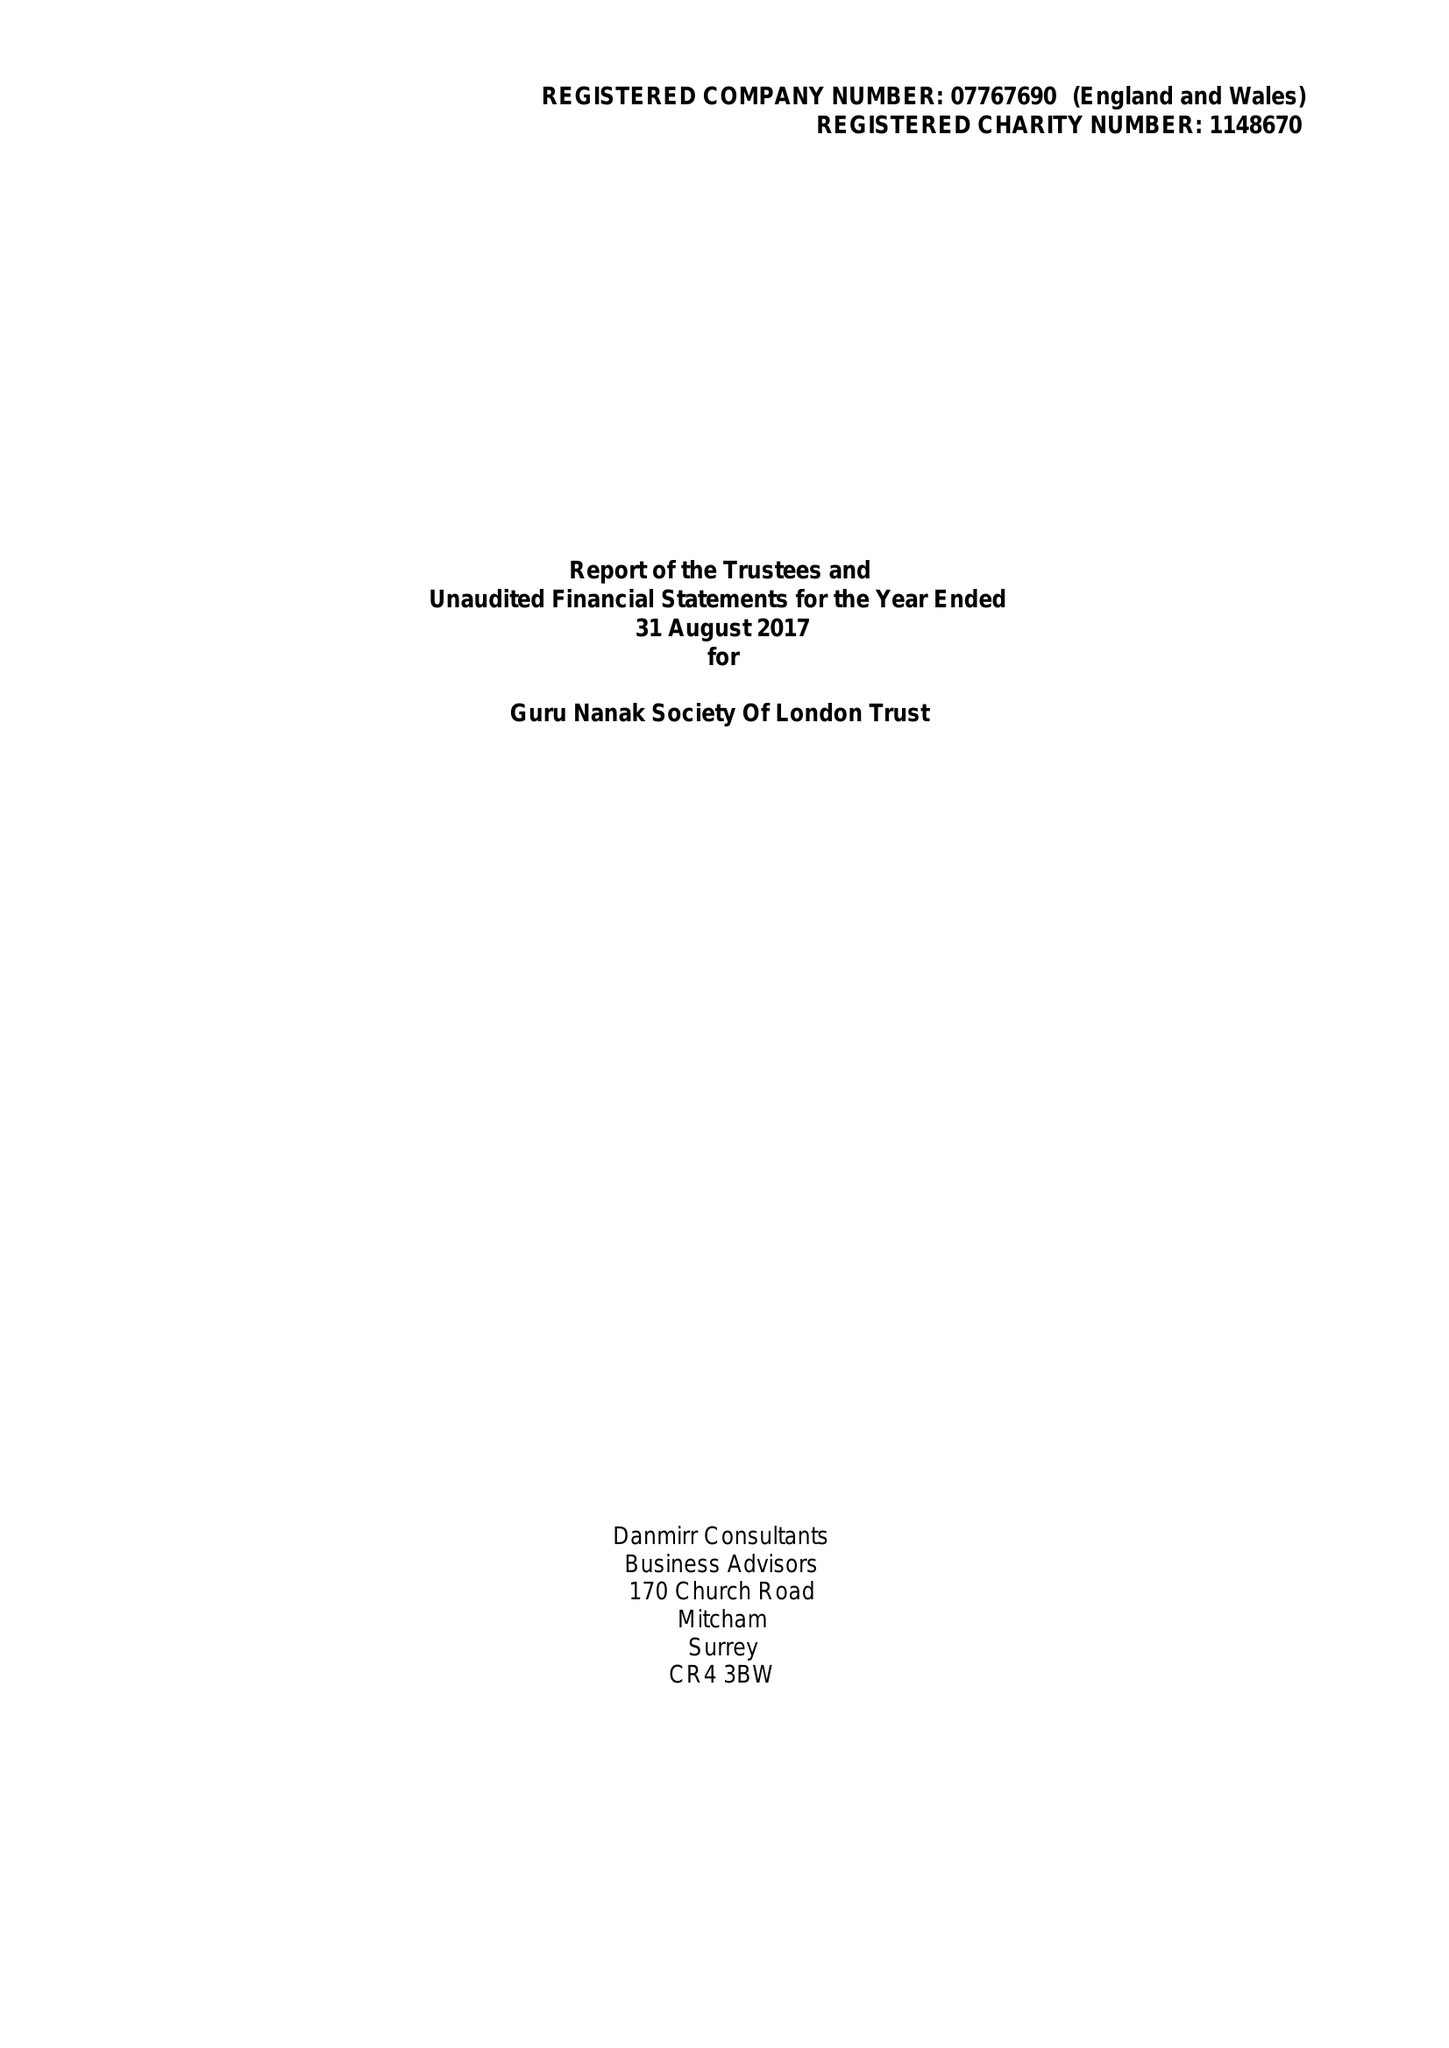What is the value for the charity_name?
Answer the question using a single word or phrase. Guru Nanak Society Of London Trust 